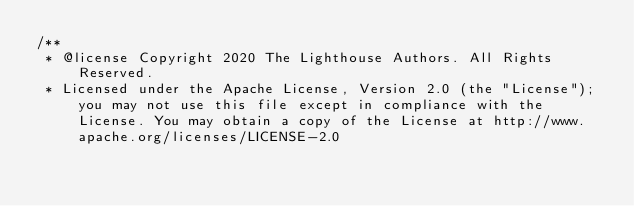<code> <loc_0><loc_0><loc_500><loc_500><_JavaScript_>/**
 * @license Copyright 2020 The Lighthouse Authors. All Rights Reserved.
 * Licensed under the Apache License, Version 2.0 (the "License"); you may not use this file except in compliance with the License. You may obtain a copy of the License at http://www.apache.org/licenses/LICENSE-2.0</code> 